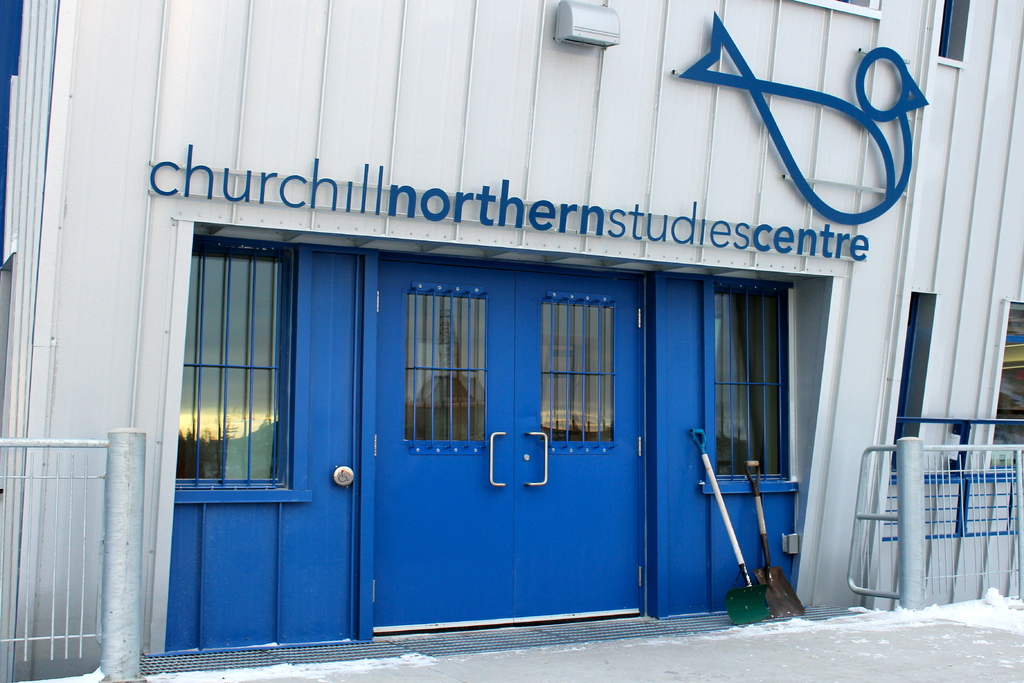Can you describe the main features of this image for me? Certainly! The image showcases the entrance of the Churchill Northern Studies Centre in Manitoba, Canada. Highlighted by vibrant blue double doors, the entrance is both inviting and functionally designed for easy access. Positioned beside the door, a green-handled shovel leans against the white building, ready for use in the snowy conditions typical for the region. The name of the center is prominently displayed above the doors in large letters, accompanied by an abstract logo, ensuring that visitors and researchers can easily identify the facility. The snowy foreground and subdued lighting suggest a cold and serene environment, typical of northern climates, perfect for the studies conducted within. 